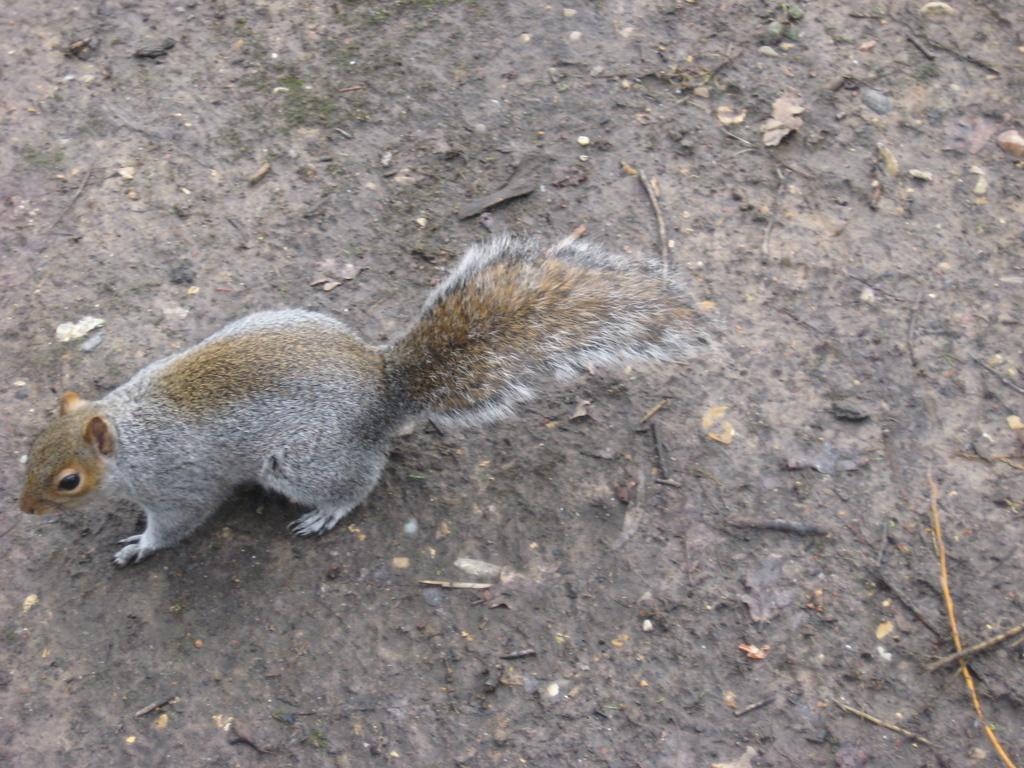What animal can be seen on the left side of the image? There is a squirrel on the left side of the image. What is the main feature in the middle of the image? There is a land in the middle of the image. What type of pets can be seen in the image? There are no pets visible in the image; only a squirrel is present. Can you tell me how many guides are present in the image? There are no guides present in the image. 